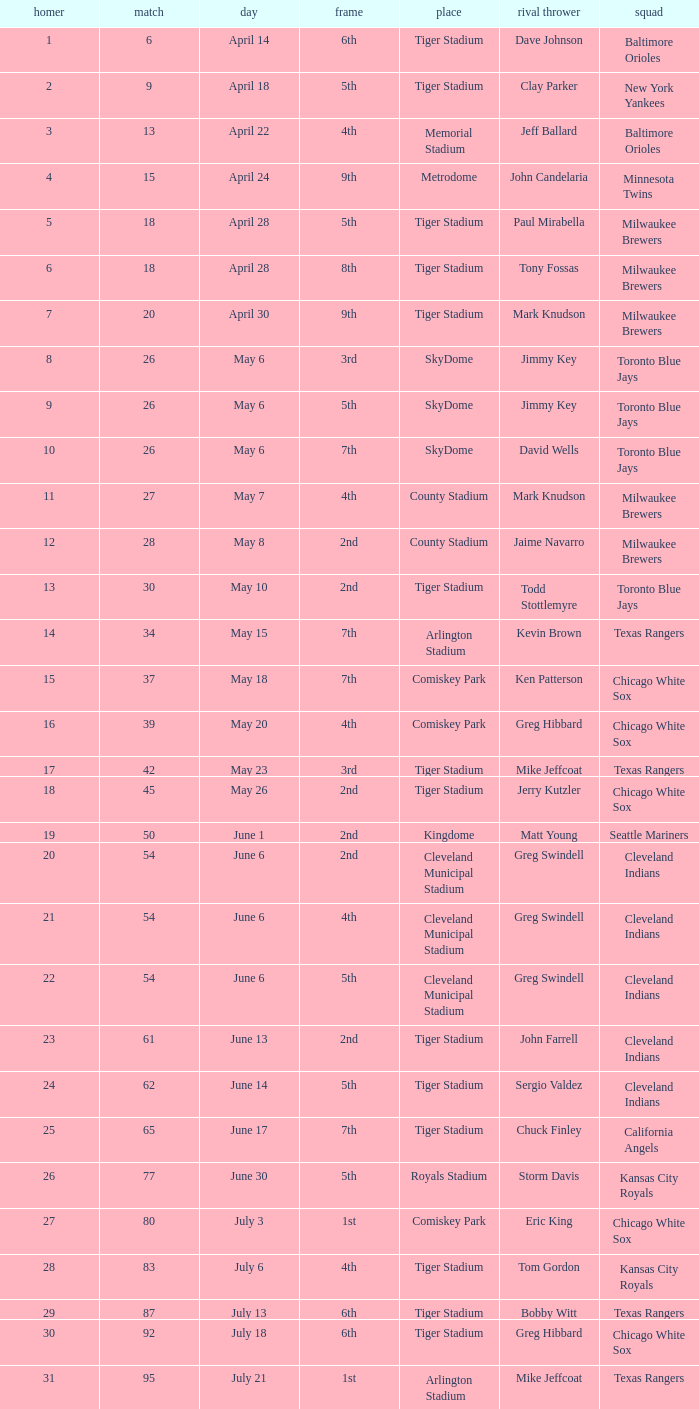When Efrain Valdez was pitching, what was the highest home run? 39.0. 